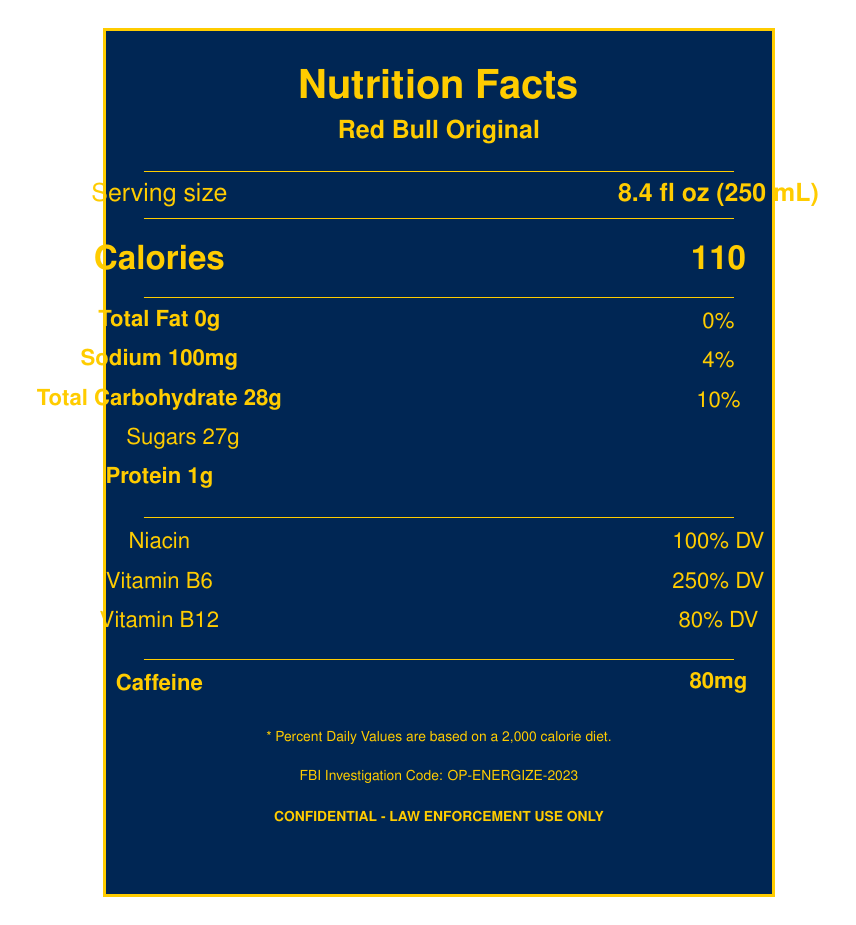what is the title of the document? The title is clearly stated at the top of the document.
Answer: Comparative Study of Nutrient Content in Energy Drinks Popular Among Suspects who conducted the study? The agency responsible for the study is mentioned right below the title.
Answer: Federal Bureau of Investigation (FBI) what is the serving size for Red Bull Original? The serving size for Red Bull Original is clearly given under the label "Serving size."
Answer: 8.4 fl oz (250 mL) how many calories are in a serving of Monster Energy Original? The number of calories for Monster Energy Original is listed as 210 in the document.
Answer: 210 what vitamins are found in Red Bull Original and their daily values? The document lists the daily values of Niacin, Vitamin B6, and Vitamin B12 for Red Bull Original.
Answer: Niacin 100% DV, Vitamin B6 250% DV, Vitamin B12 80% DV which energy drink has the highest sugar content? A. Red Bull Original B. Monster Energy Original C. Rockstar Original Rockstar Original has the highest sugar content with 60g of sugars.
Answer: C what is the caffeine content in Rockstar Original? The caffeine content of Rockstar Original is stated as 160mg in the document.
Answer: 160mg which energy drink is most popular among suspects? A. Red Bull Original B. Monster Energy Original C. Rockstar Original Red Bull Original is described as having "Very High" popularity among suspects.
Answer: A is the protein content high in Monster Energy Original? Monster Energy Original has 0g of protein, which is not considered high.
Answer: No summarize the main findings of the study The document highlights key findings such as caffeine preference, sugar variations, B-vitamin consistency, and serving size impact.
Answer: Suspects tend to prefer energy drinks with higher caffeine content, sugar content varies, B-vitamin fortification is consistent, and serving sizes impact nutrient intake. why might suspects prefer energy drinks with higher caffeine content? The study suggests that high caffeine intake may lead to increased alertness and erratic behavior, which might be desirable for some suspects.
Answer: Increased alertness and potential erratic behavior what percentage of the daily value does Vitamin B6 provide in Monster Energy Original? The document indicates that Vitamin B6 in Monster Energy Original provides 200% of the daily value.
Answer: 200% DV what methods were used to collect data for this study? The data collection methods are listed as part of the document's description.
Answer: Analysis of discarded containers, surveillance of purchases, interviews with suspects, toxicology reports what is the total fat content in a serving of Red Bull Original? The total fat content for Red Bull Original is explicitly mentioned as 0g.
Answer: 0g does Rockstar Original have the highest sodium content? Monster Energy Original has the highest sodium content with 370mg, compared to 120mg in Rockstar Original.
Answer: No what are the recommended actions following the study? The document lists recommendations for actions following the study.
Answer: Monitor sales patterns, develop profiles, educate field agents, collaborate with forensic labs how many milligrams of sodium are in a serving of Red Bull Original? The sodium content for Red Bull Original is listed as 100mg in the document.
Answer: 100mg how many grams of carbohydrates does Rockstar Original contain? Rockstar Original contains 62g of total carbohydrates.
Answer: 62g which energy drink contains the least caffeine? A. Red Bull Original B. Monster Energy Original C. Rockstar Original Red Bull Original has the least caffeine at 80mg.
Answer: A how often are B-vitamins fortified across these energy drinks? The document notes that B-vitamin fortification is consistent across the popular brands.
Answer: Consistently how does sugar content vary among the energy drinks? The sugar content varies significantly as detailed in the document.
Answer: Significantly, with Red Bull Original at 27g, Monster Energy Original at 54g, and Rockstar Original at 60g how can sugar consumption patterns provide insights into suspect movements and habits? The investigative implications section mentions that sugar consumption patterns could offer insights into suspect behaviors.
Answer: Analysis of the types and amounts of energy drinks consumed can reveal preferences and patterns, possibly indicating certain behaviors or routines of suspects. what is the daily value percentage of Vitamin B12 in Rockstar Original? According to the document, Vitamin B12 provides 200% of the daily value in Rockstar Original.
Answer: 200% DV how can caffeine intake affect suspect behavior? The key findings section mentions that high caffeine intake may lead to these effects.
Answer: It can lead to increased alertness and erratic behavior. cannot determine the exact dietary needs based on document alone? The document provides nutrient content but does not specify individual dietary needs.
Answer: Not enough information 